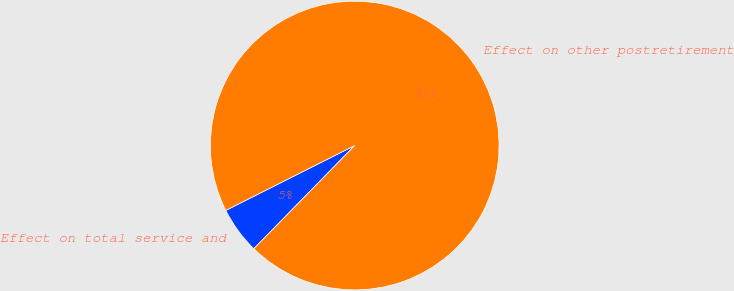Convert chart. <chart><loc_0><loc_0><loc_500><loc_500><pie_chart><fcel>Effect on total service and<fcel>Effect on other postretirement<nl><fcel>5.26%<fcel>94.74%<nl></chart> 